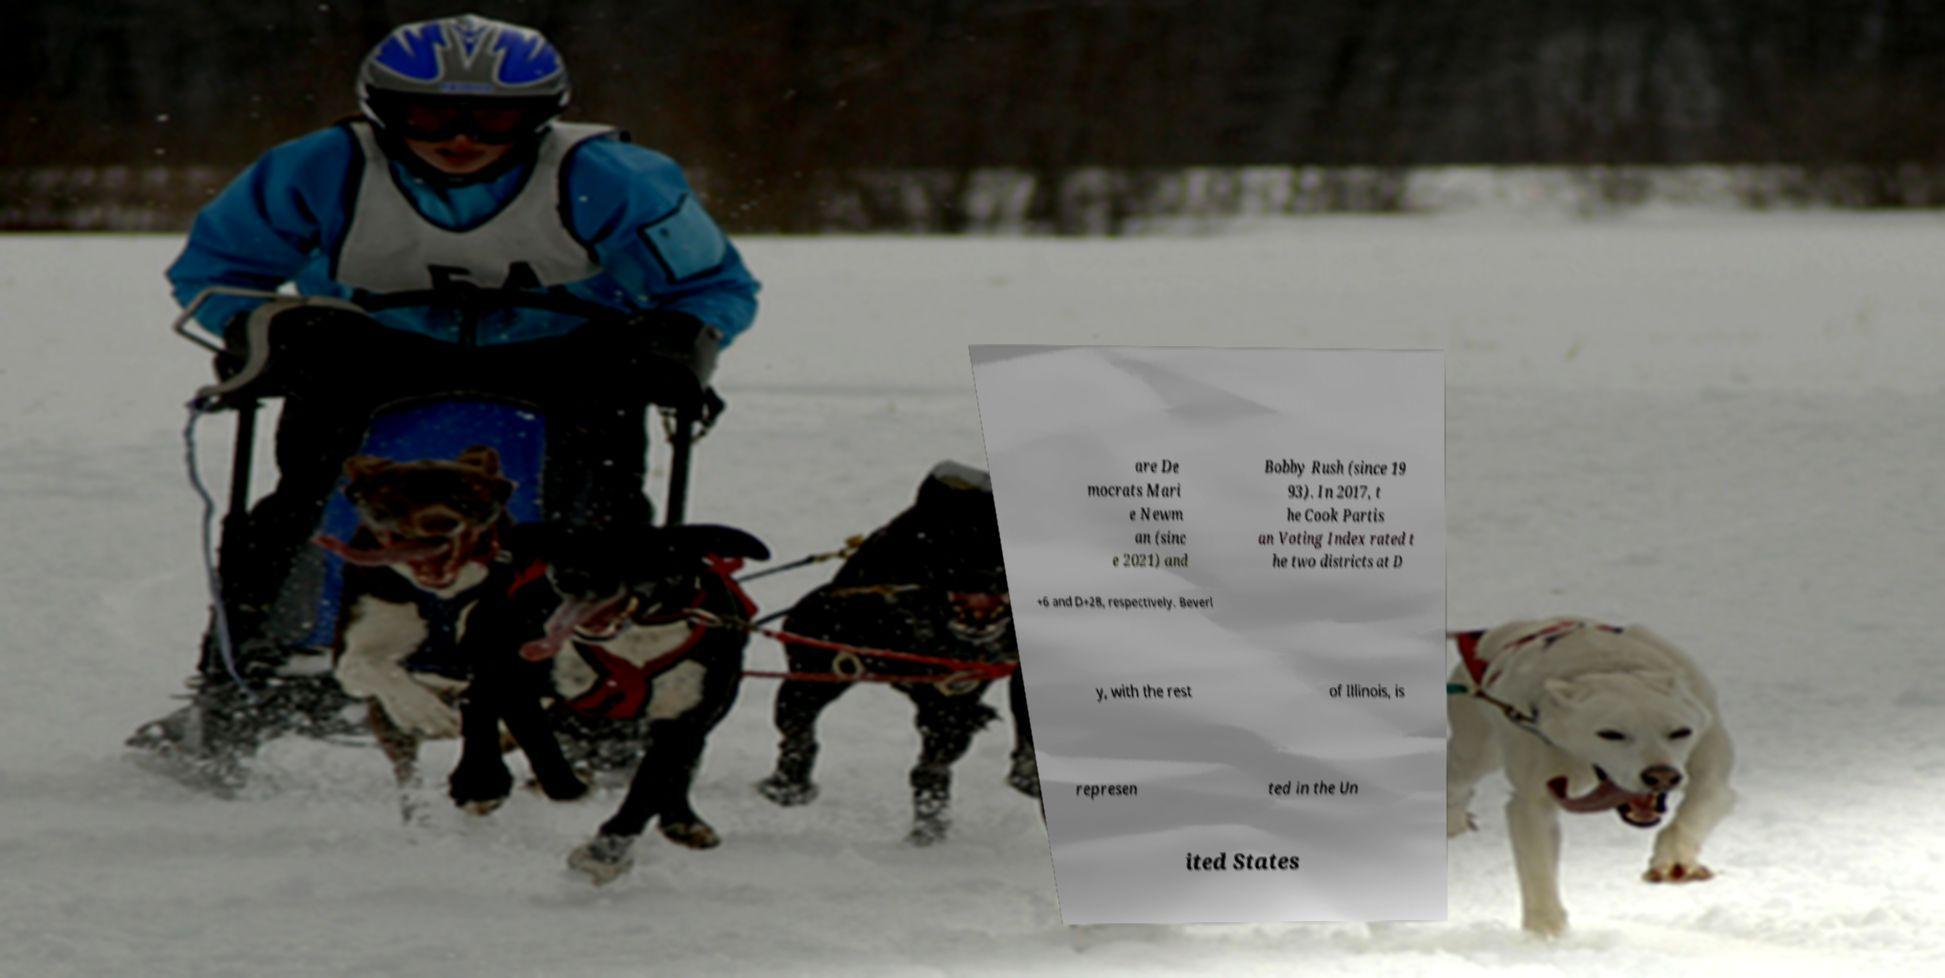What messages or text are displayed in this image? I need them in a readable, typed format. are De mocrats Mari e Newm an (sinc e 2021) and Bobby Rush (since 19 93). In 2017, t he Cook Partis an Voting Index rated t he two districts at D +6 and D+28, respectively. Beverl y, with the rest of Illinois, is represen ted in the Un ited States 